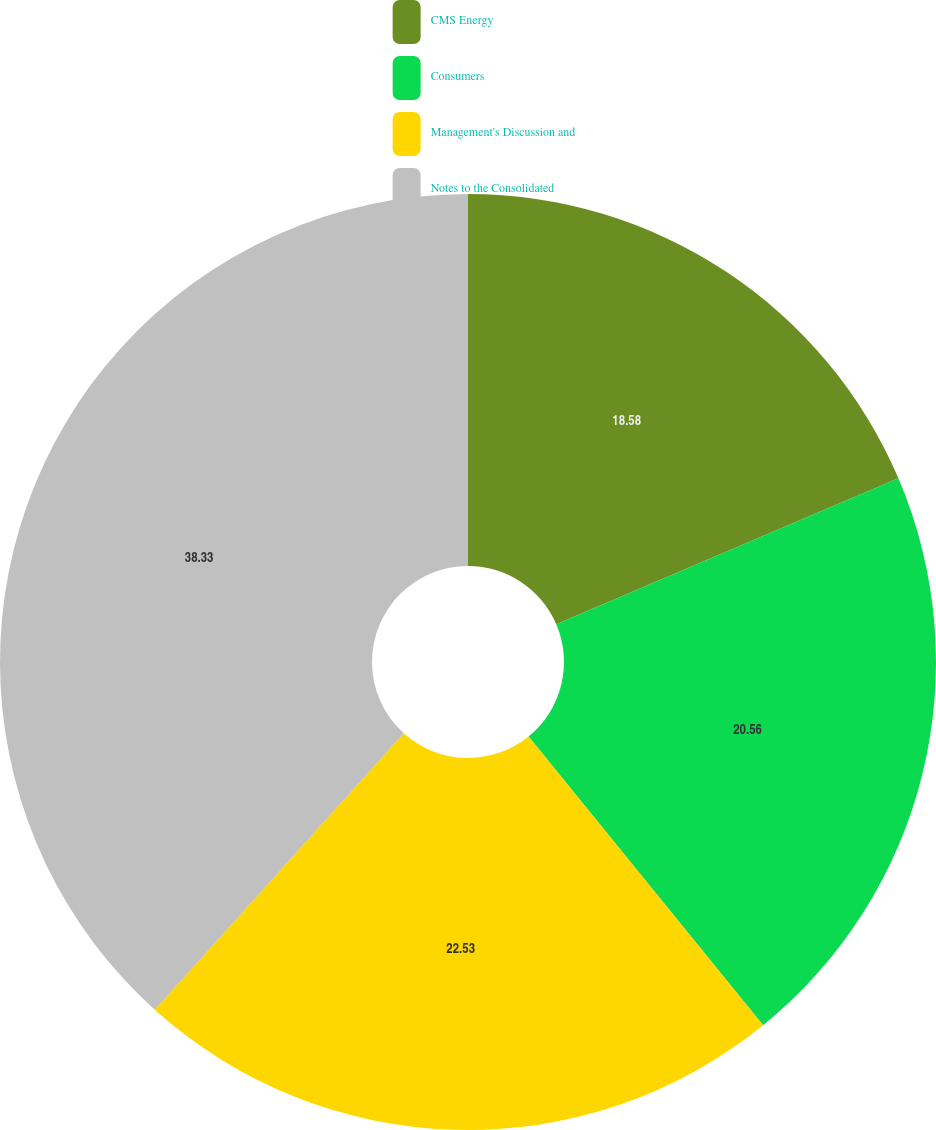Convert chart to OTSL. <chart><loc_0><loc_0><loc_500><loc_500><pie_chart><fcel>CMS Energy<fcel>Consumers<fcel>Management's Discussion and<fcel>Notes to the Consolidated<nl><fcel>18.58%<fcel>20.56%<fcel>22.53%<fcel>38.33%<nl></chart> 